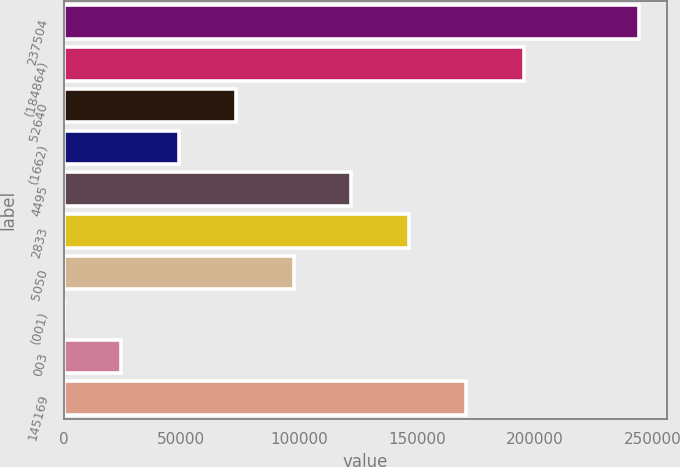Convert chart. <chart><loc_0><loc_0><loc_500><loc_500><bar_chart><fcel>237504<fcel>(184864)<fcel>52640<fcel>(1662)<fcel>4495<fcel>2833<fcel>5050<fcel>(001)<fcel>003<fcel>145169<nl><fcel>243943<fcel>195154<fcel>73182.9<fcel>48788.6<fcel>121972<fcel>146366<fcel>97577.2<fcel>0.04<fcel>24394.3<fcel>170760<nl></chart> 